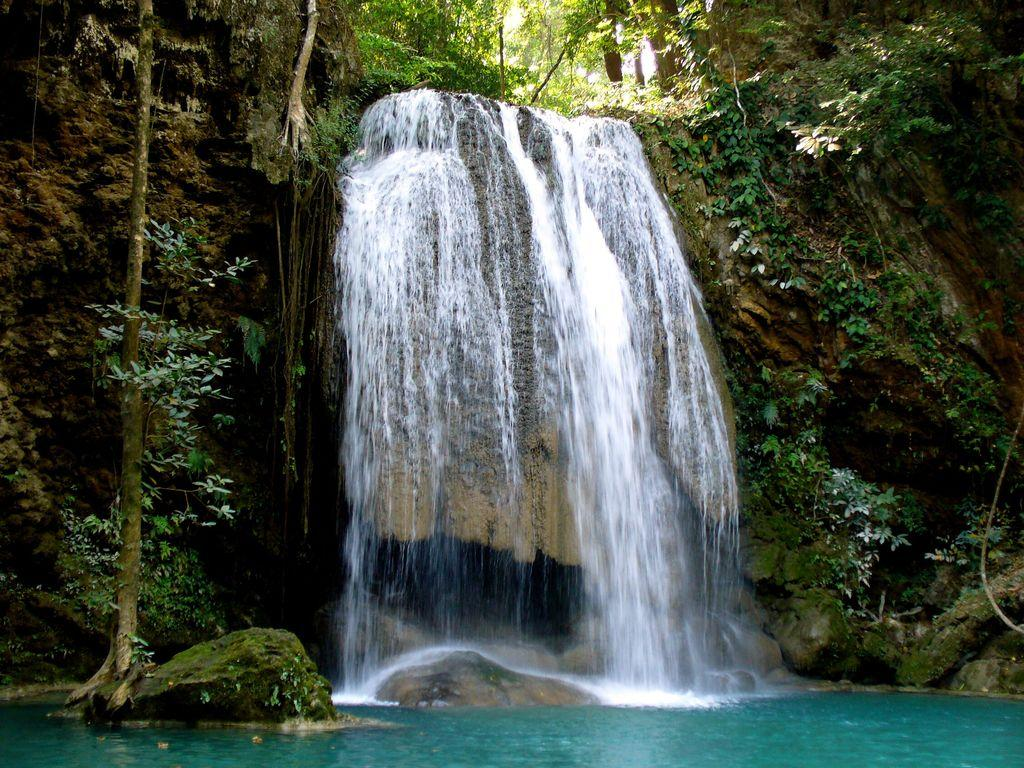What is the main feature in the center of the image? There is a waterfall in the center of the image. What type of vegetation can be seen on the right side of the image? There are trees on the right side of the image. What type of vegetation can be seen on the left side of the image? There are trees on the left side of the image. What else is present in the image besides the waterfall and trees? There are plants in the image. What is visible at the bottom of the image? There is water at the bottom of the image. How does the waterfall aid in the digestion process of the nearby animals in the image? There are no animals present in the image, and the waterfall's role in the digestion process cannot be determined. What type of oranges can be seen growing on the trees in the image? There are no oranges present in the image; the trees are not fruit-bearing trees. 